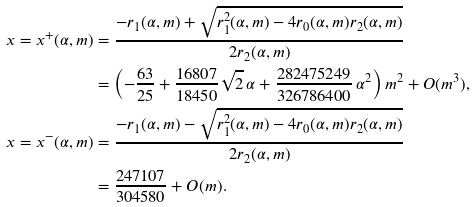Convert formula to latex. <formula><loc_0><loc_0><loc_500><loc_500>x = x ^ { + } ( \alpha , m ) & = \frac { - r _ { 1 } ( \alpha , m ) + \sqrt { r _ { 1 } ^ { 2 } ( \alpha , m ) - 4 r _ { 0 } ( \alpha , m ) r _ { 2 } ( \alpha , m ) } } { 2 r _ { 2 } ( \alpha , m ) } \\ & = \left ( - \frac { 6 3 } { 2 5 } + \frac { 1 6 8 0 7 } { 1 8 4 5 0 } \sqrt { 2 } \, \alpha + \frac { 2 8 2 4 7 5 2 4 9 } { 3 2 6 7 8 6 4 0 0 } \, \alpha ^ { 2 } \right ) m ^ { 2 } + O ( m ^ { 3 } ) , \\ x = x ^ { - } ( \alpha , m ) & = \frac { - r _ { 1 } ( \alpha , m ) - \sqrt { r _ { 1 } ^ { 2 } ( \alpha , m ) - 4 r _ { 0 } ( \alpha , m ) r _ { 2 } ( \alpha , m ) } } { 2 r _ { 2 } ( \alpha , m ) } \\ & = \frac { 2 4 7 1 0 7 } { 3 0 4 5 8 0 } + O ( m ) .</formula> 